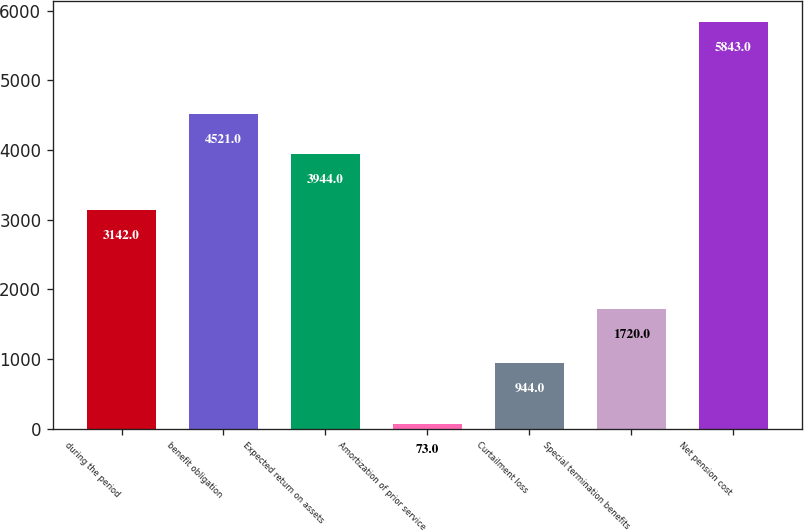<chart> <loc_0><loc_0><loc_500><loc_500><bar_chart><fcel>during the period<fcel>benefit obligation<fcel>Expected return on assets<fcel>Amortization of prior service<fcel>Curtailment loss<fcel>Special termination benefits<fcel>Net pension cost<nl><fcel>3142<fcel>4521<fcel>3944<fcel>73<fcel>944<fcel>1720<fcel>5843<nl></chart> 